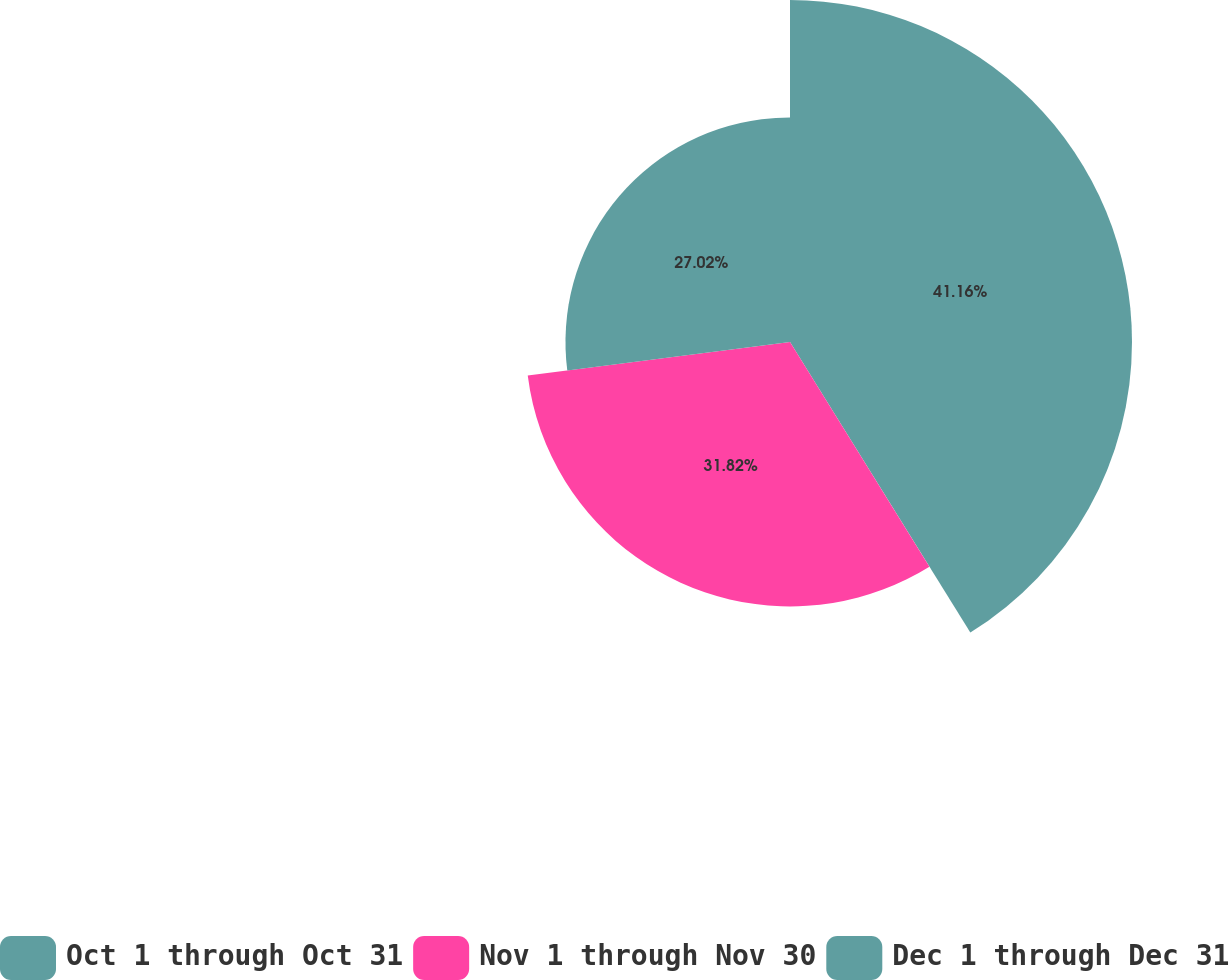Convert chart. <chart><loc_0><loc_0><loc_500><loc_500><pie_chart><fcel>Oct 1 through Oct 31<fcel>Nov 1 through Nov 30<fcel>Dec 1 through Dec 31<nl><fcel>41.16%<fcel>31.82%<fcel>27.02%<nl></chart> 